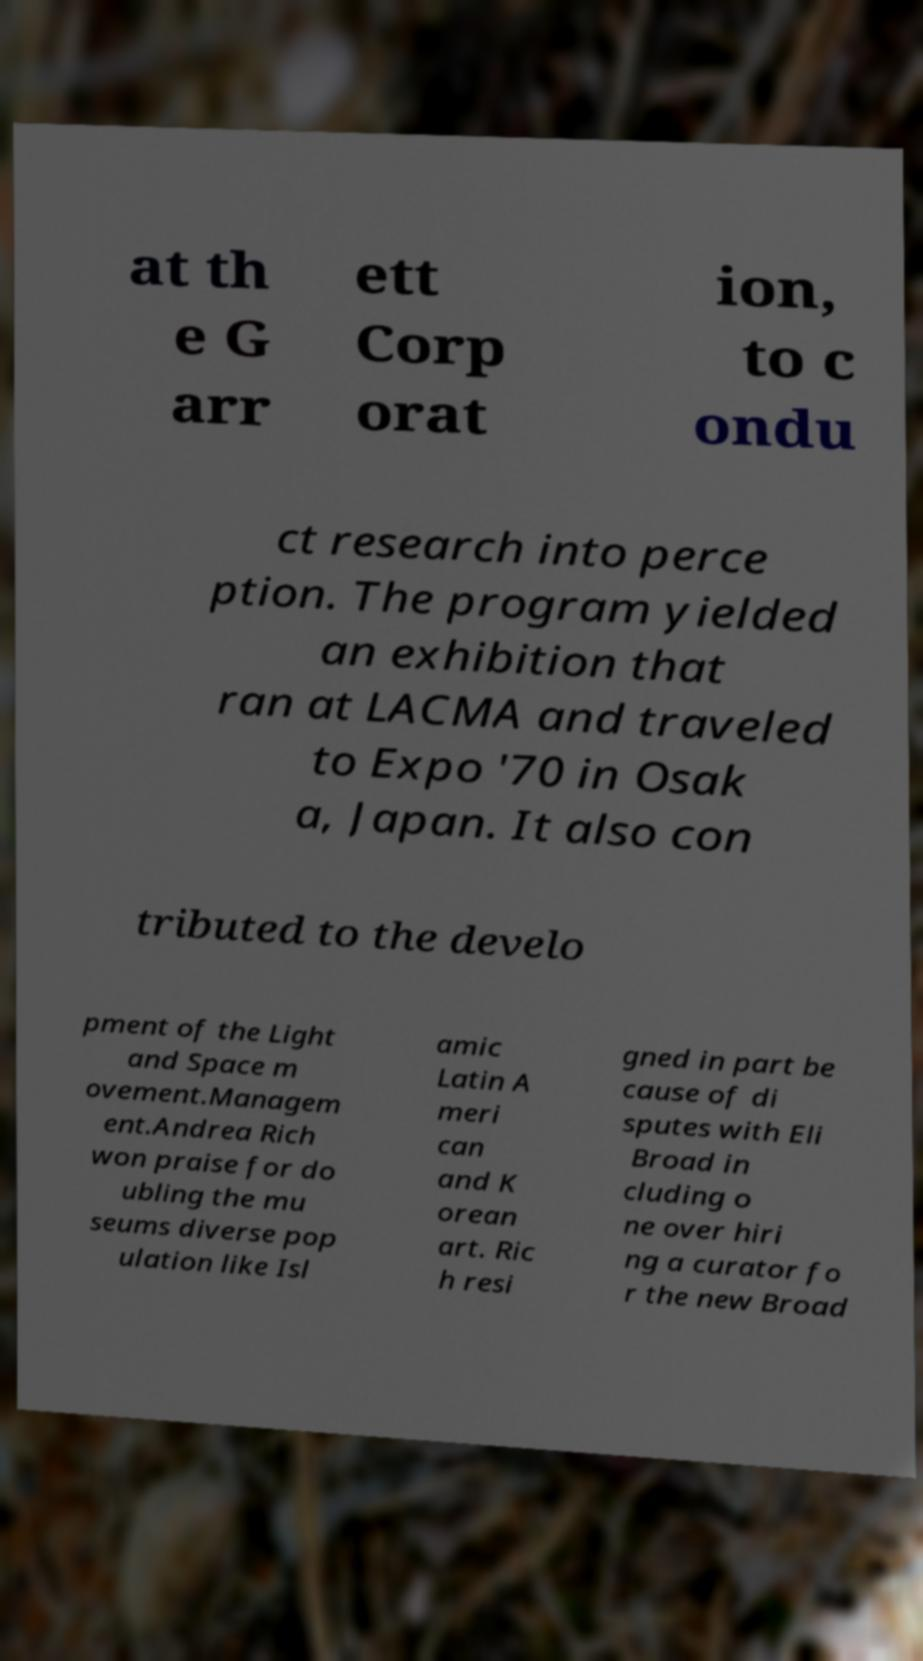Could you extract and type out the text from this image? at th e G arr ett Corp orat ion, to c ondu ct research into perce ption. The program yielded an exhibition that ran at LACMA and traveled to Expo '70 in Osak a, Japan. It also con tributed to the develo pment of the Light and Space m ovement.Managem ent.Andrea Rich won praise for do ubling the mu seums diverse pop ulation like Isl amic Latin A meri can and K orean art. Ric h resi gned in part be cause of di sputes with Eli Broad in cluding o ne over hiri ng a curator fo r the new Broad 